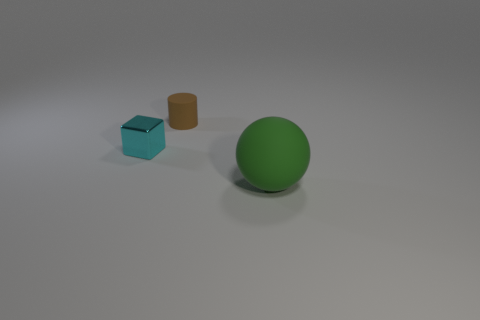Is there any other thing that is the same size as the rubber sphere?
Make the answer very short. No. Is there any other thing that is the same material as the cyan object?
Provide a short and direct response. No. There is a object that is both right of the tiny cube and in front of the cylinder; what is its material?
Offer a very short reply. Rubber. What number of brown cylinders are in front of the small metallic object?
Your answer should be very brief. 0. How many big gray matte objects are there?
Give a very brief answer. 0. Is the cylinder the same size as the cyan metallic object?
Keep it short and to the point. Yes. There is a tiny thing that is on the right side of the small cyan cube that is left of the rubber cylinder; is there a matte object to the right of it?
Your response must be concise. Yes. What color is the rubber thing that is in front of the brown matte object?
Offer a terse response. Green. The cyan cube is what size?
Give a very brief answer. Small. There is a brown matte thing; is it the same size as the sphere on the right side of the tiny metal object?
Provide a succinct answer. No. 